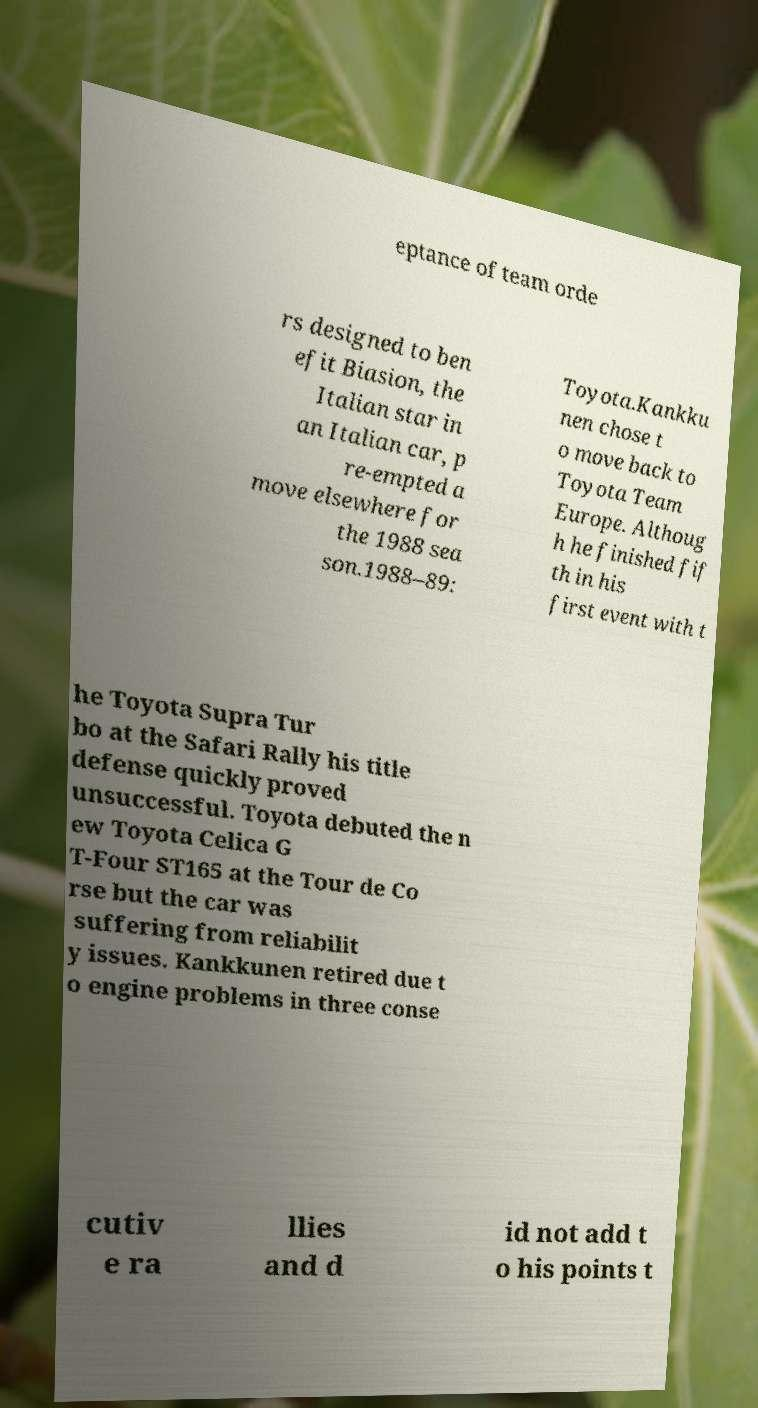What messages or text are displayed in this image? I need them in a readable, typed format. eptance of team orde rs designed to ben efit Biasion, the Italian star in an Italian car, p re-empted a move elsewhere for the 1988 sea son.1988–89: Toyota.Kankku nen chose t o move back to Toyota Team Europe. Althoug h he finished fif th in his first event with t he Toyota Supra Tur bo at the Safari Rally his title defense quickly proved unsuccessful. Toyota debuted the n ew Toyota Celica G T-Four ST165 at the Tour de Co rse but the car was suffering from reliabilit y issues. Kankkunen retired due t o engine problems in three conse cutiv e ra llies and d id not add t o his points t 